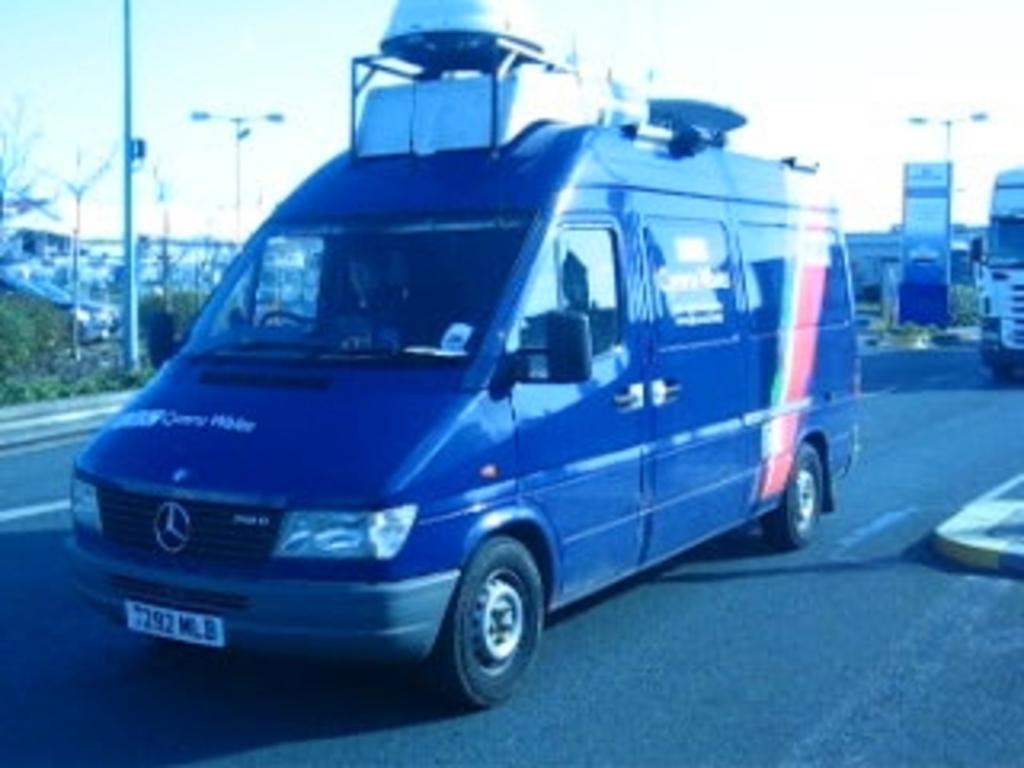What is the license plate code for the van?
Offer a terse response. 7292 mlb. 